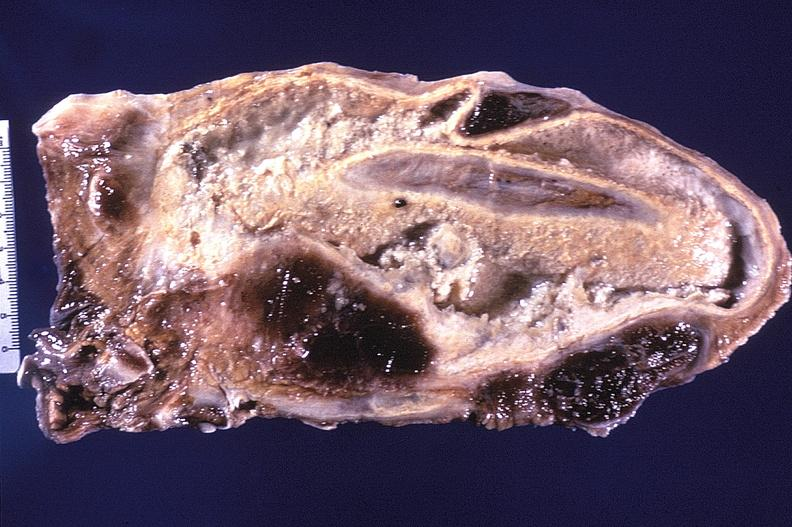what does this image show?
Answer the question using a single word or phrase. Tuberculosis 